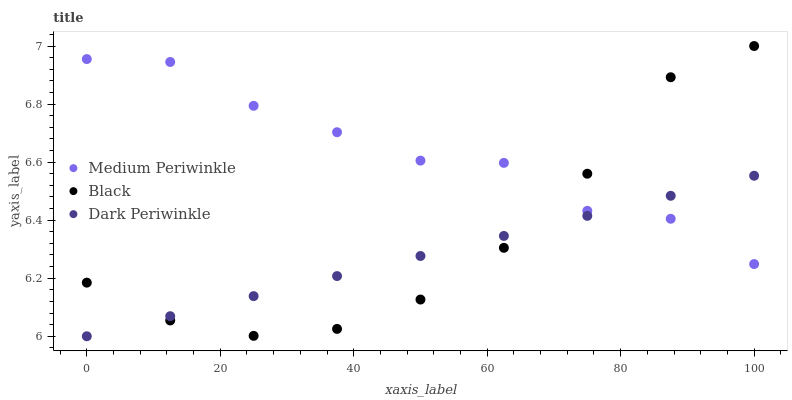Does Dark Periwinkle have the minimum area under the curve?
Answer yes or no. Yes. Does Medium Periwinkle have the maximum area under the curve?
Answer yes or no. Yes. Does Medium Periwinkle have the minimum area under the curve?
Answer yes or no. No. Does Dark Periwinkle have the maximum area under the curve?
Answer yes or no. No. Is Dark Periwinkle the smoothest?
Answer yes or no. Yes. Is Medium Periwinkle the roughest?
Answer yes or no. Yes. Is Medium Periwinkle the smoothest?
Answer yes or no. No. Is Dark Periwinkle the roughest?
Answer yes or no. No. Does Dark Periwinkle have the lowest value?
Answer yes or no. Yes. Does Medium Periwinkle have the lowest value?
Answer yes or no. No. Does Black have the highest value?
Answer yes or no. Yes. Does Medium Periwinkle have the highest value?
Answer yes or no. No. Does Black intersect Medium Periwinkle?
Answer yes or no. Yes. Is Black less than Medium Periwinkle?
Answer yes or no. No. Is Black greater than Medium Periwinkle?
Answer yes or no. No. 